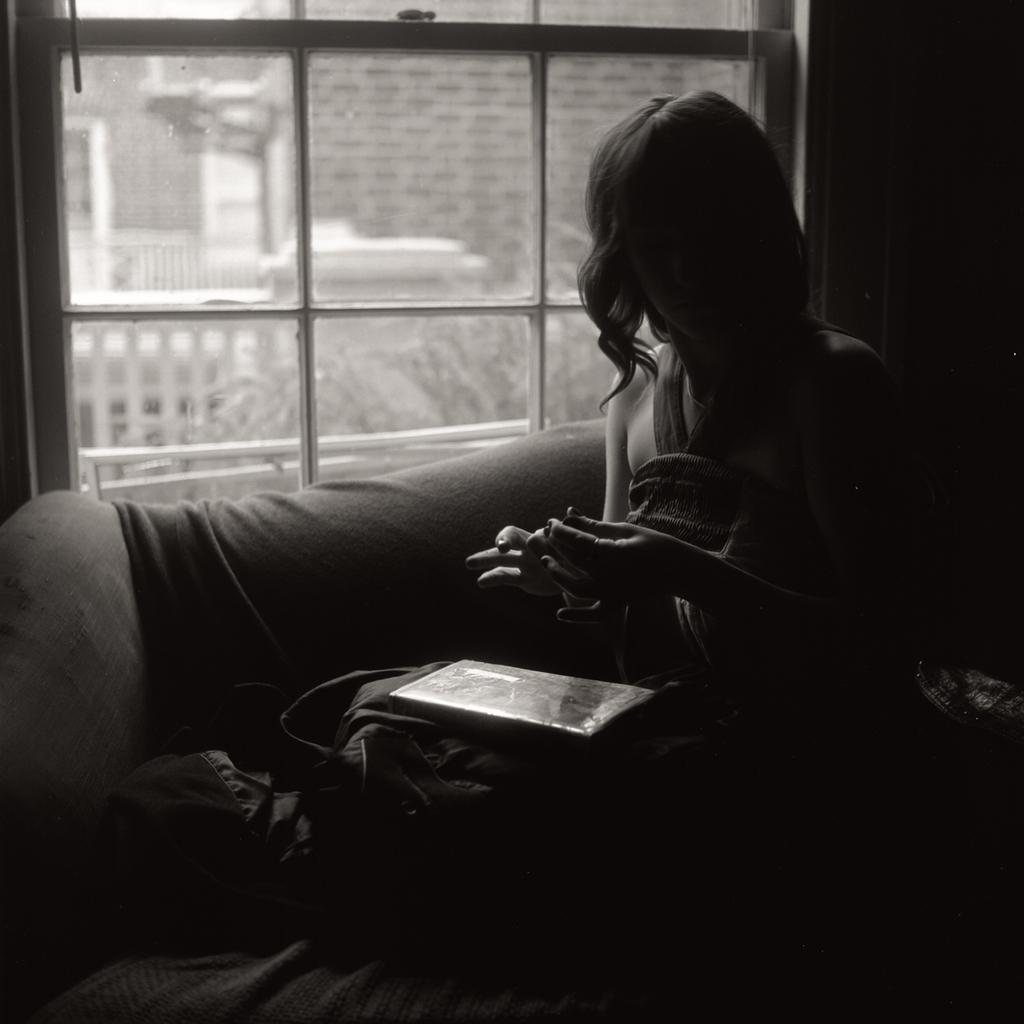Who is present in the image? There is a woman in the image. What is the woman doing in the image? The woman is sitting on a sofa. What can be seen in the background of the image? There is a glass window in the background of the image. What type of pancake can be seen on the woman's plate in the image? There is no plate or pancake present in the image. 